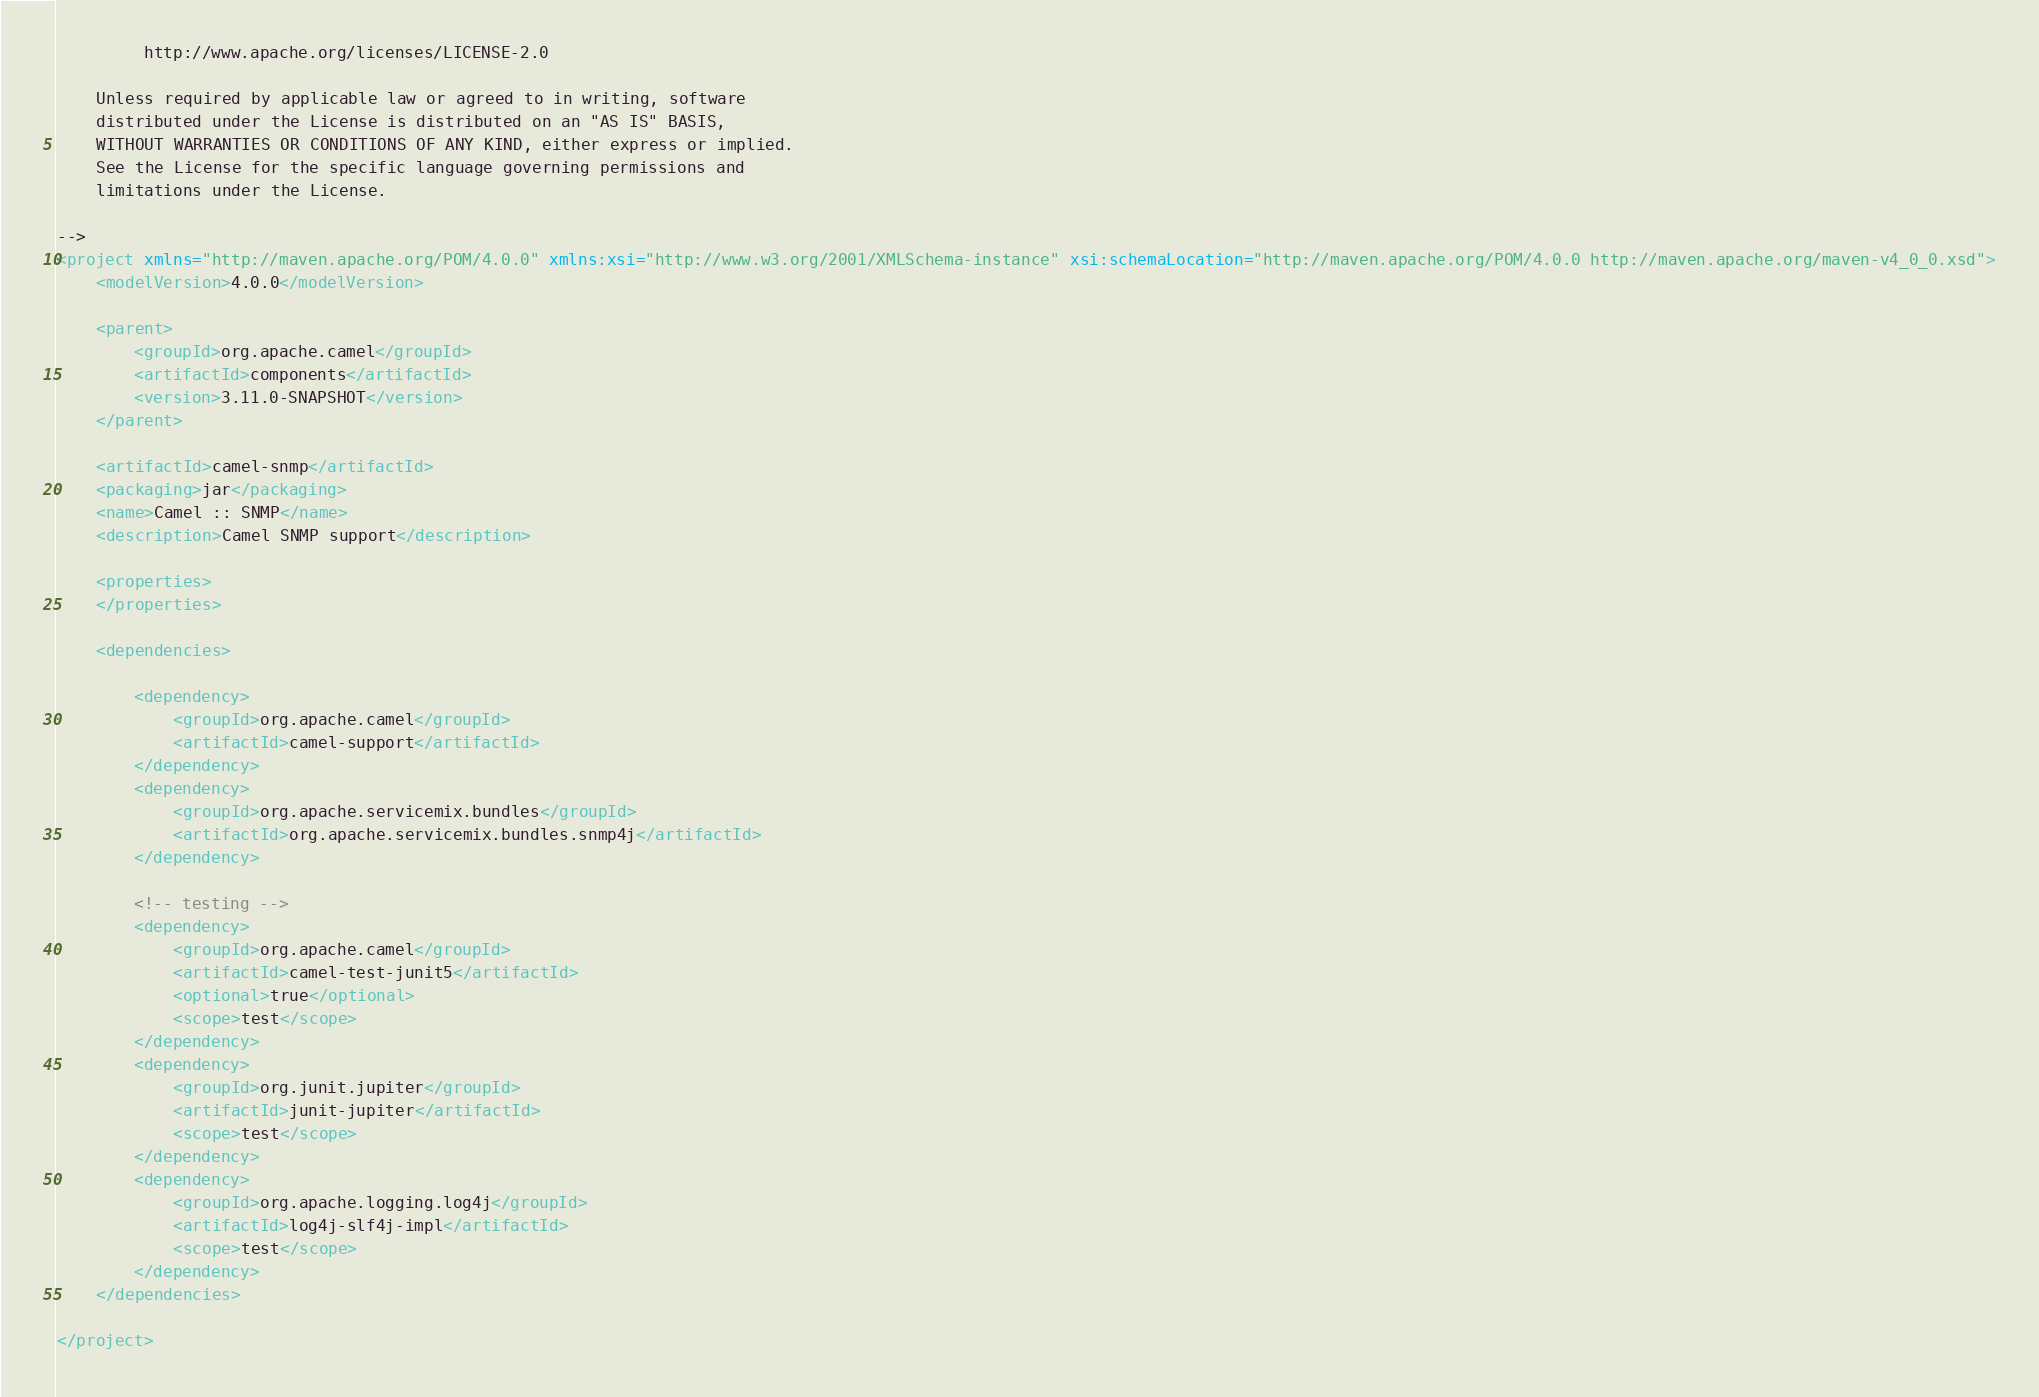Convert code to text. <code><loc_0><loc_0><loc_500><loc_500><_XML_>         http://www.apache.org/licenses/LICENSE-2.0

    Unless required by applicable law or agreed to in writing, software
    distributed under the License is distributed on an "AS IS" BASIS,
    WITHOUT WARRANTIES OR CONDITIONS OF ANY KIND, either express or implied.
    See the License for the specific language governing permissions and
    limitations under the License.

-->
<project xmlns="http://maven.apache.org/POM/4.0.0" xmlns:xsi="http://www.w3.org/2001/XMLSchema-instance" xsi:schemaLocation="http://maven.apache.org/POM/4.0.0 http://maven.apache.org/maven-v4_0_0.xsd">
    <modelVersion>4.0.0</modelVersion>

    <parent>
        <groupId>org.apache.camel</groupId>
        <artifactId>components</artifactId>
        <version>3.11.0-SNAPSHOT</version>
    </parent>

    <artifactId>camel-snmp</artifactId>
    <packaging>jar</packaging>
    <name>Camel :: SNMP</name>
    <description>Camel SNMP support</description>

    <properties>
    </properties>

    <dependencies>

        <dependency>
            <groupId>org.apache.camel</groupId>
            <artifactId>camel-support</artifactId>
        </dependency>
        <dependency>
            <groupId>org.apache.servicemix.bundles</groupId>
            <artifactId>org.apache.servicemix.bundles.snmp4j</artifactId>
        </dependency>

        <!-- testing -->
        <dependency>
            <groupId>org.apache.camel</groupId>
            <artifactId>camel-test-junit5</artifactId>
            <optional>true</optional>
            <scope>test</scope>
        </dependency>
        <dependency>
            <groupId>org.junit.jupiter</groupId>
            <artifactId>junit-jupiter</artifactId>
            <scope>test</scope>
        </dependency>
        <dependency>
            <groupId>org.apache.logging.log4j</groupId>
            <artifactId>log4j-slf4j-impl</artifactId>
            <scope>test</scope>
        </dependency>
    </dependencies>

</project>
</code> 